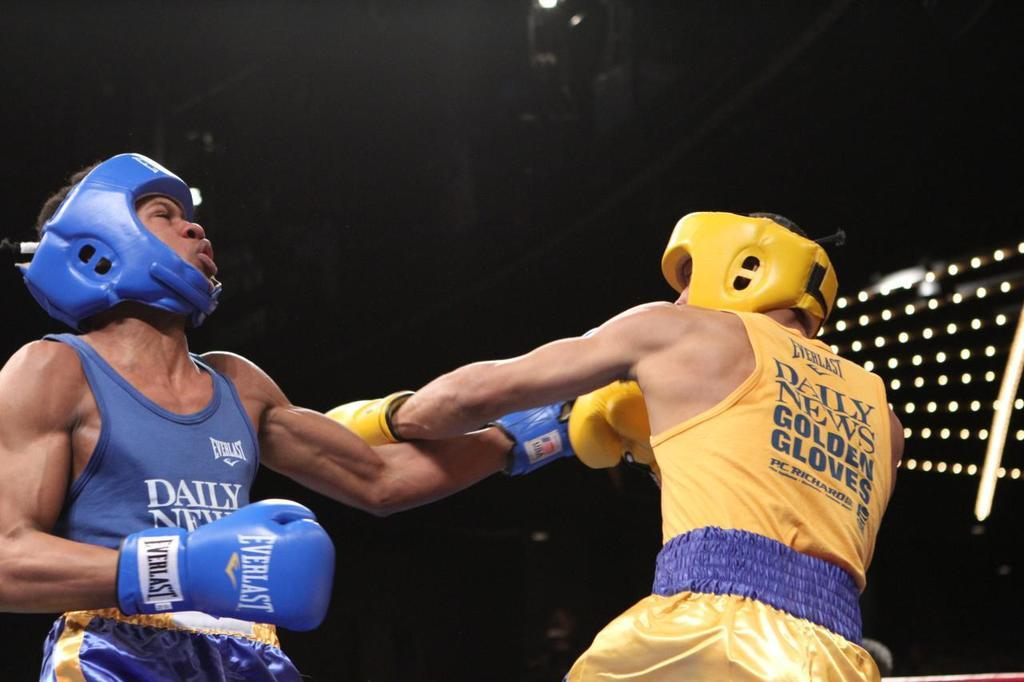<image>
Share a concise interpretation of the image provided. Two male boxers with one blue shirt reading daily on it 